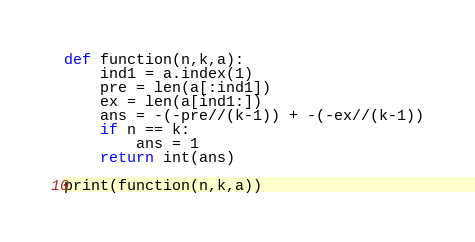<code> <loc_0><loc_0><loc_500><loc_500><_Python_>def function(n,k,a):
    ind1 = a.index(1)
    pre = len(a[:ind1])
    ex = len(a[ind1:])    
    ans = -(-pre//(k-1)) + -(-ex//(k-1))
    if n == k:
        ans = 1
    return int(ans)

print(function(n,k,a))</code> 